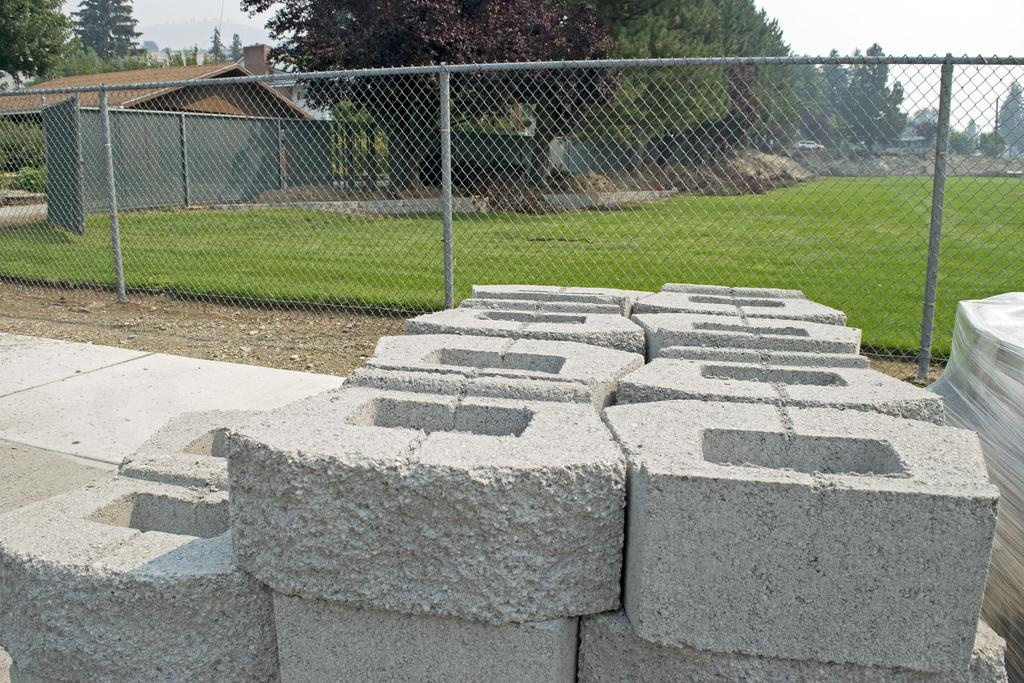What type of objects are located at the bottom side of the image? There are stones at the bottom side of the image. What can be seen in the image besides the stones? There is a net in the image. What is visible in the background of the image? There is grassland, trees, and houses in the background of the image. What type of rhythm can be heard coming from the crowd in the image? There is no crowd present in the image, so it's not possible to determine what rhythm might be heard. 